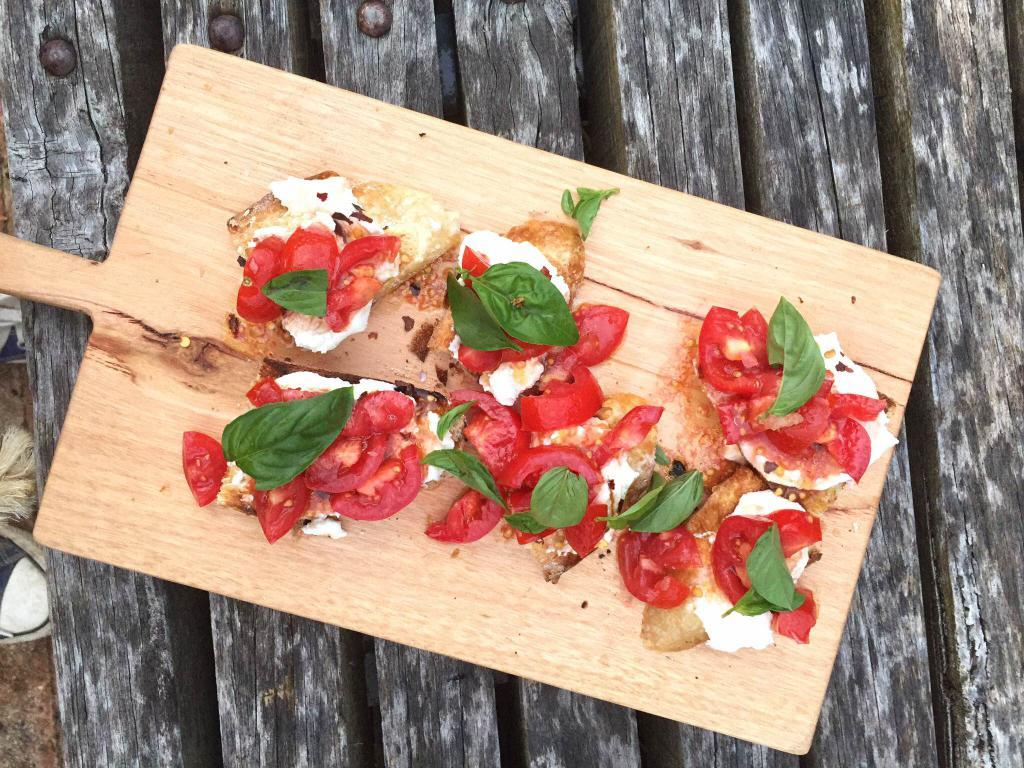What type of table is in the image? There is a wooden table in the image. What is placed on the wooden table? There is a chopping board on the table. What is on the chopping board? There are fruits and leaves on the chopping board. What type of question is being asked on the chopping board? There is no question present on the chopping board; it contains fruits and leaves. 